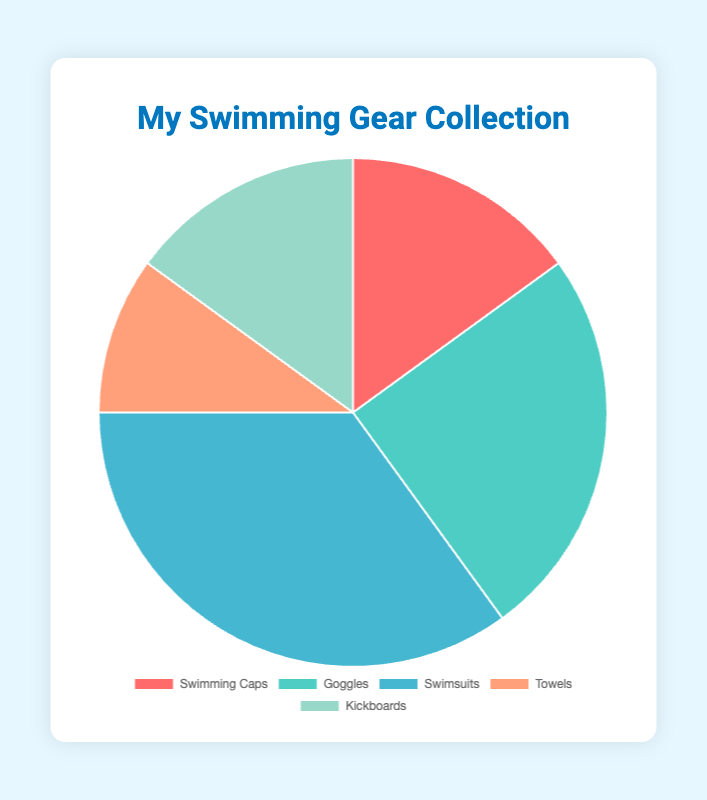Which type of swimming gear has the highest percentage? The type of swimming gear with the highest percentage is evident from the largest segment in the pie chart, which represents 35%. This type is Swimsuits.
Answer: Swimsuits What is the combined percentage of Swimming Caps and Kickboards? To find the combined percentage, add the percentages of Swimming Caps (15%) and Kickboards (15%). Thus, the combined percentage is 15% + 15% = 30%.
Answer: 30% Which type of swimming gear has the least representation in the pie chart? The smallest segment in the pie chart represents 10%. Therefore, the type with the least representation is Towels.
Answer: Towels By how much does the percentage of Goggles exceed the percentage of Towels? The percentage of Goggles is 25%, and the percentage of Towels is 10%. Subtract the percentage of Towels from the percentage of Goggles: 25% - 10% = 15%. Therefore, Goggles exceed Towels by 15%.
Answer: 15% Given that the total percentage must sum to 100%, what's the percentage of non-swimsuit gear? To find the non-swimsuit gear percentage, subtract the Swimsuits percentage (35%) from 100%: 100% - 35% = 65%.
Answer: 65% Which gear types have an equal representation in the pie chart? Looking at the segments, Swimming Caps and Kickboards each have a 15% representation. Hence, these two types have equal representation.
Answer: Swimming Caps and Kickboards Compare the sum of the percentages for Goggles and Swimsuits to the sum of the percentages for Swimming Caps and Kickboards. Which sum is larger? Calculate the sum of Goggles and Swimsuits: 25% + 35% = 60%. Calculate the sum of Swimming Caps and Kickboards: 15% + 15% = 30%. The sum of Goggles and Swimsuits (60%) is larger than the sum of Swimming Caps and Kickboards (30%).
Answer: Goggles and Swimsuits What percentage of the swimming gear falls into categories that are neither Goggles nor Swimsuits? To find the percentage of gear that is neither Goggles nor Swimsuits, sum the percentages of Swimming Caps (15%), Towels (10%), and Kickboards (15%): 15% + 10% + 15% = 40%.
Answer: 40% Describe the color used for the Swimsuits segment in the pie chart. The Swimsuits segment has a distinct color, which is identified as blue based on its visual appearance in the pie chart.
Answer: Blue 